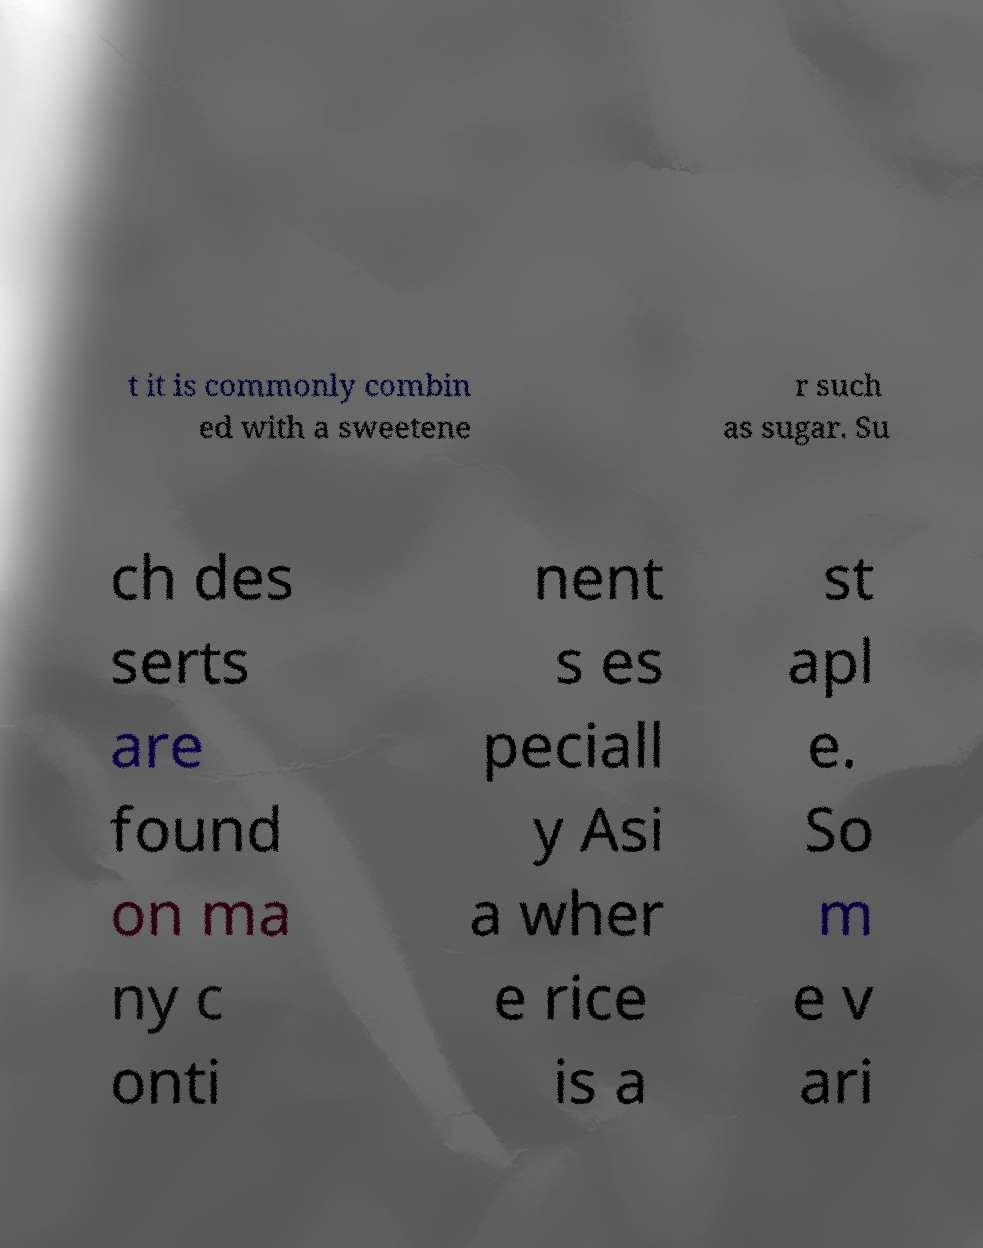Could you extract and type out the text from this image? t it is commonly combin ed with a sweetene r such as sugar. Su ch des serts are found on ma ny c onti nent s es peciall y Asi a wher e rice is a st apl e. So m e v ari 